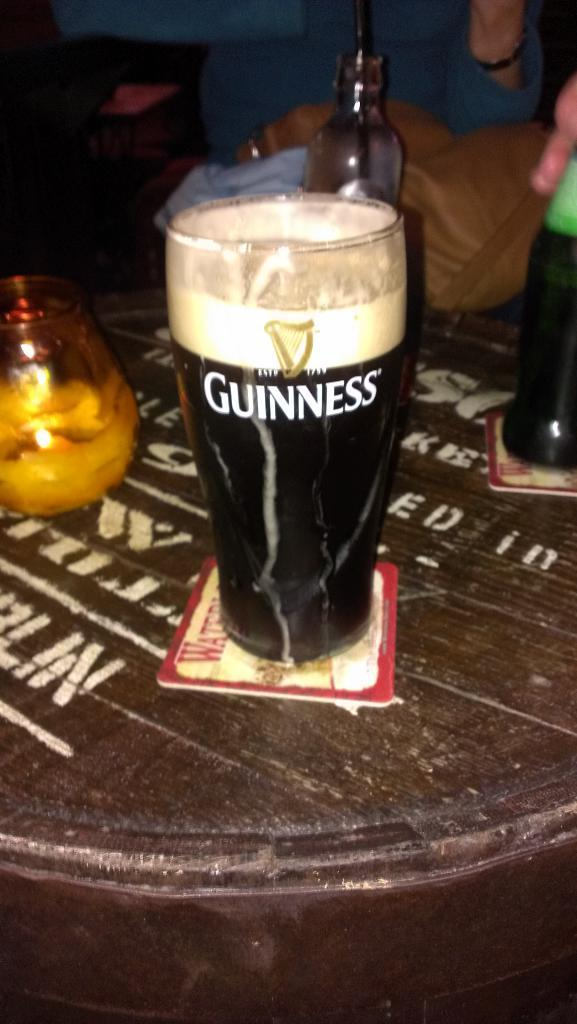Provide a one-sentence caption for the provided image. A pint glass full of Guinness sits on a coaster. 